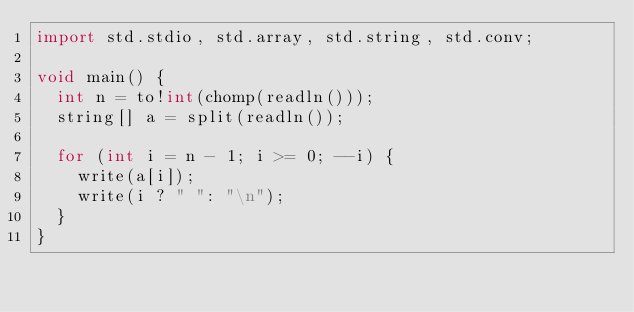<code> <loc_0><loc_0><loc_500><loc_500><_D_>import std.stdio, std.array, std.string, std.conv;

void main() {
  int n = to!int(chomp(readln()));
  string[] a = split(readln());

  for (int i = n - 1; i >= 0; --i) {
    write(a[i]);
    write(i ? " ": "\n");
  }
}</code> 